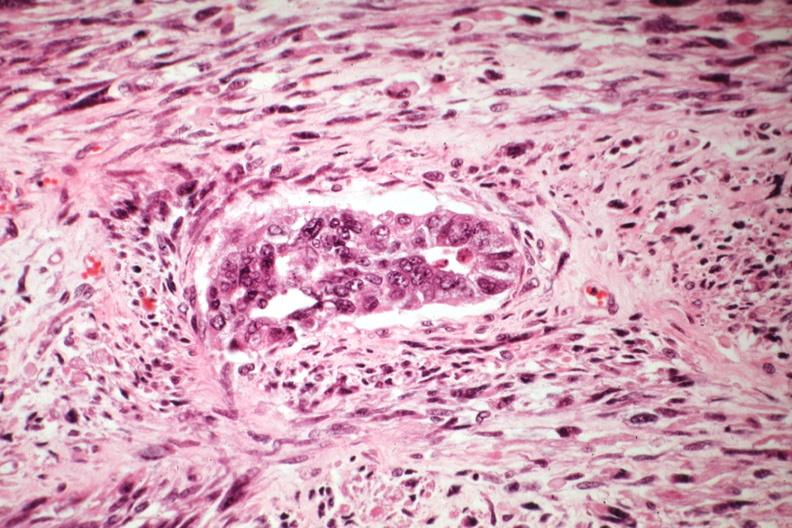where is this from?
Answer the question using a single word or phrase. Female reproductive system 